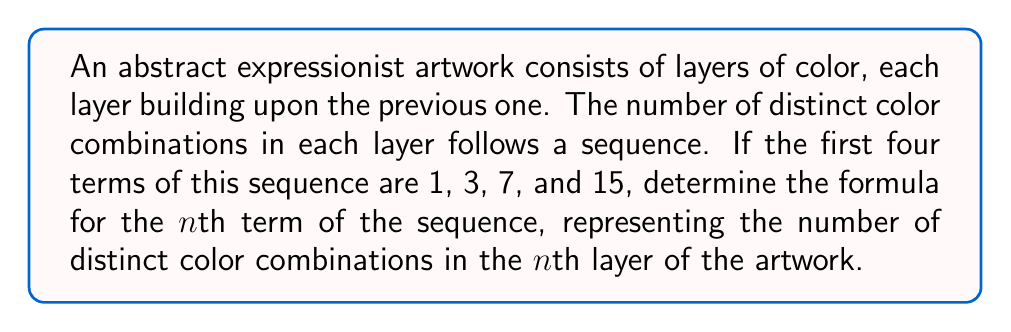Solve this math problem. Let's approach this step-by-step:

1) First, let's examine the given terms of the sequence:
   $a_1 = 1$
   $a_2 = 3$
   $a_3 = 7$
   $a_4 = 15$

2) Now, let's look at the differences between consecutive terms:
   $3 - 1 = 2$
   $7 - 3 = 4$
   $15 - 7 = 8$

3) We can see that these differences form a geometric sequence: 2, 4, 8
   This suggests that each term is doubling: $2^1, 2^2, 2^3$

4) Let's express each term of the original sequence in terms of powers of 2:
   $a_1 = 1 = 2^1 - 1$
   $a_2 = 3 = 2^2 - 1$
   $a_3 = 7 = 2^3 - 1$
   $a_4 = 15 = 2^4 - 1$

5) We can now see the pattern: for the nth term, we have:
   $a_n = 2^n - 1$

6) This formula makes sense in the context of color layers. Each new layer doubles the possible combinations (as it can be present or absent) and we subtract 1 to exclude the case where no colors are used.

Therefore, the formula for the nth term of the sequence is $a_n = 2^n - 1$.
Answer: $a_n = 2^n - 1$ 